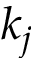Convert formula to latex. <formula><loc_0><loc_0><loc_500><loc_500>k _ { j }</formula> 